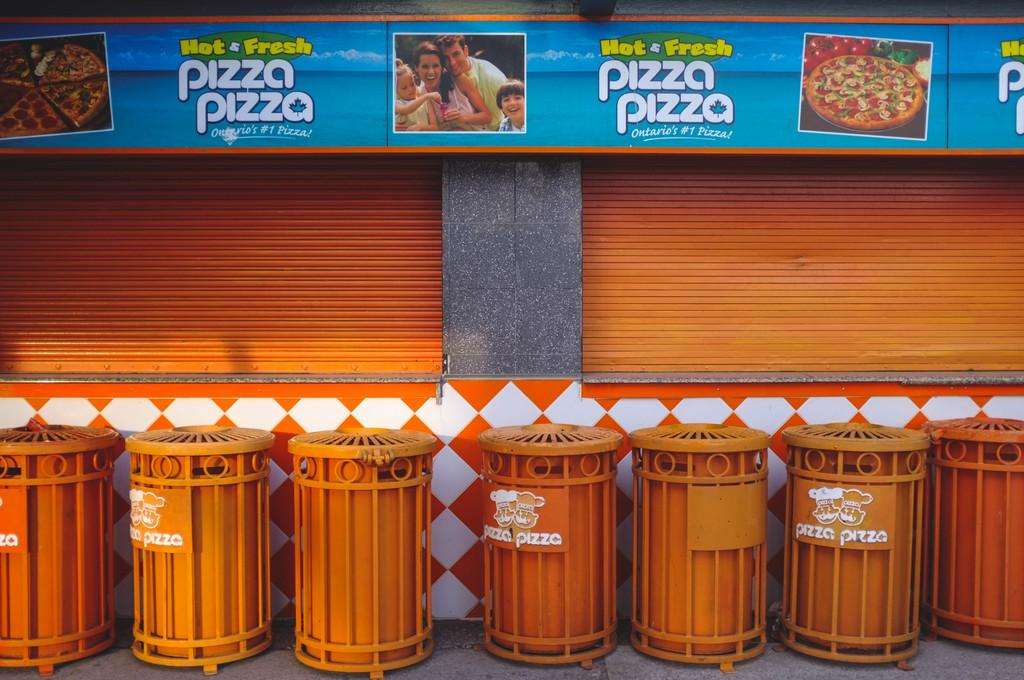<image>
Render a clear and concise summary of the photo. Orange garbage bins under a sign which says "Hot & Fresh". 